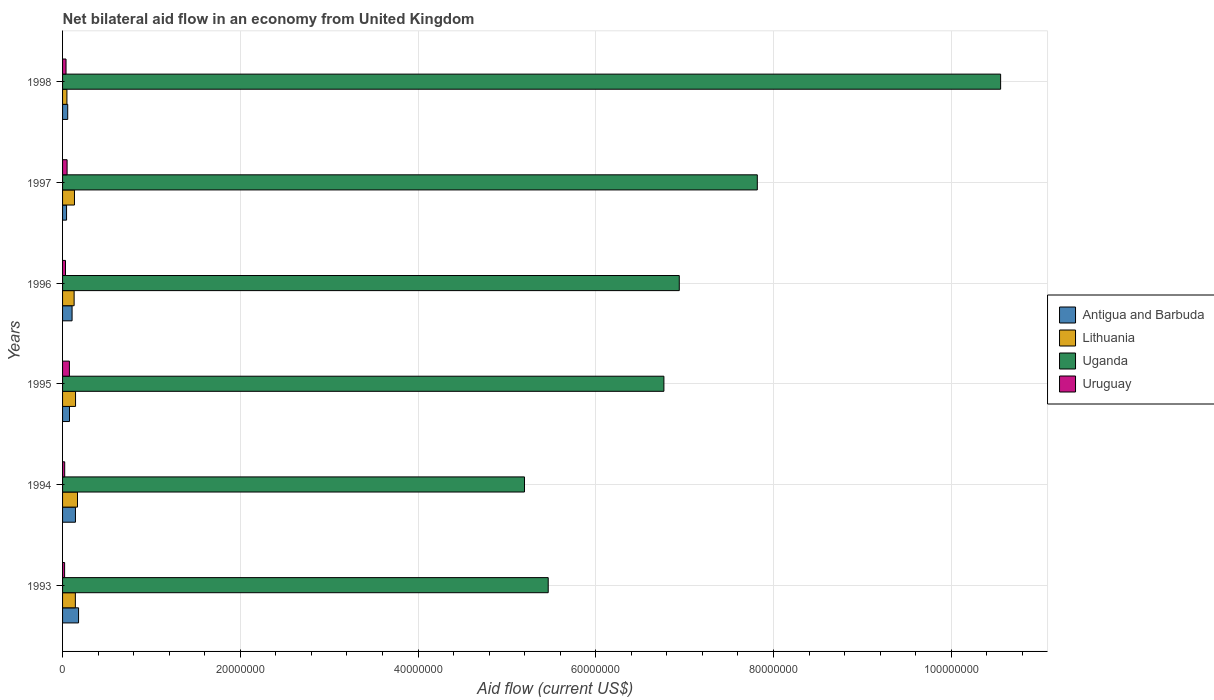How many different coloured bars are there?
Make the answer very short. 4. Are the number of bars per tick equal to the number of legend labels?
Your answer should be very brief. Yes. How many bars are there on the 4th tick from the top?
Keep it short and to the point. 4. What is the net bilateral aid flow in Lithuania in 1994?
Your response must be concise. 1.68e+06. Across all years, what is the maximum net bilateral aid flow in Uruguay?
Your answer should be very brief. 7.70e+05. What is the total net bilateral aid flow in Uruguay in the graph?
Make the answer very short. 2.47e+06. What is the difference between the net bilateral aid flow in Antigua and Barbuda in 1993 and that in 1994?
Offer a terse response. 3.50e+05. What is the difference between the net bilateral aid flow in Uganda in 1993 and the net bilateral aid flow in Uruguay in 1997?
Offer a very short reply. 5.41e+07. What is the average net bilateral aid flow in Lithuania per year?
Provide a succinct answer. 1.28e+06. In the year 1997, what is the difference between the net bilateral aid flow in Uruguay and net bilateral aid flow in Antigua and Barbuda?
Your answer should be very brief. 6.00e+04. What is the ratio of the net bilateral aid flow in Uruguay in 1995 to that in 1998?
Make the answer very short. 1.97. What is the difference between the highest and the lowest net bilateral aid flow in Uganda?
Your answer should be very brief. 5.36e+07. Is it the case that in every year, the sum of the net bilateral aid flow in Uruguay and net bilateral aid flow in Lithuania is greater than the sum of net bilateral aid flow in Uganda and net bilateral aid flow in Antigua and Barbuda?
Give a very brief answer. No. What does the 4th bar from the top in 1993 represents?
Your answer should be compact. Antigua and Barbuda. What does the 3rd bar from the bottom in 1994 represents?
Give a very brief answer. Uganda. Is it the case that in every year, the sum of the net bilateral aid flow in Uganda and net bilateral aid flow in Lithuania is greater than the net bilateral aid flow in Antigua and Barbuda?
Make the answer very short. Yes. How many bars are there?
Provide a short and direct response. 24. Are all the bars in the graph horizontal?
Your response must be concise. Yes. How many years are there in the graph?
Ensure brevity in your answer.  6. What is the difference between two consecutive major ticks on the X-axis?
Your response must be concise. 2.00e+07. Are the values on the major ticks of X-axis written in scientific E-notation?
Your answer should be compact. No. Where does the legend appear in the graph?
Your answer should be compact. Center right. How many legend labels are there?
Provide a succinct answer. 4. What is the title of the graph?
Provide a short and direct response. Net bilateral aid flow in an economy from United Kingdom. What is the label or title of the Y-axis?
Your answer should be compact. Years. What is the Aid flow (current US$) in Antigua and Barbuda in 1993?
Provide a succinct answer. 1.80e+06. What is the Aid flow (current US$) in Lithuania in 1993?
Your answer should be compact. 1.44e+06. What is the Aid flow (current US$) in Uganda in 1993?
Offer a very short reply. 5.46e+07. What is the Aid flow (current US$) in Uruguay in 1993?
Make the answer very short. 2.30e+05. What is the Aid flow (current US$) of Antigua and Barbuda in 1994?
Offer a terse response. 1.45e+06. What is the Aid flow (current US$) in Lithuania in 1994?
Ensure brevity in your answer.  1.68e+06. What is the Aid flow (current US$) in Uganda in 1994?
Keep it short and to the point. 5.20e+07. What is the Aid flow (current US$) in Antigua and Barbuda in 1995?
Your answer should be compact. 7.80e+05. What is the Aid flow (current US$) in Lithuania in 1995?
Your answer should be compact. 1.46e+06. What is the Aid flow (current US$) of Uganda in 1995?
Give a very brief answer. 6.77e+07. What is the Aid flow (current US$) in Uruguay in 1995?
Make the answer very short. 7.70e+05. What is the Aid flow (current US$) in Antigua and Barbuda in 1996?
Ensure brevity in your answer.  1.07e+06. What is the Aid flow (current US$) in Lithuania in 1996?
Your answer should be compact. 1.30e+06. What is the Aid flow (current US$) of Uganda in 1996?
Offer a very short reply. 6.94e+07. What is the Aid flow (current US$) in Uruguay in 1996?
Provide a succinct answer. 3.30e+05. What is the Aid flow (current US$) of Lithuania in 1997?
Make the answer very short. 1.34e+06. What is the Aid flow (current US$) in Uganda in 1997?
Provide a short and direct response. 7.82e+07. What is the Aid flow (current US$) in Uruguay in 1997?
Ensure brevity in your answer.  5.10e+05. What is the Aid flow (current US$) in Antigua and Barbuda in 1998?
Make the answer very short. 5.80e+05. What is the Aid flow (current US$) of Uganda in 1998?
Make the answer very short. 1.06e+08. What is the Aid flow (current US$) of Uruguay in 1998?
Your response must be concise. 3.90e+05. Across all years, what is the maximum Aid flow (current US$) in Antigua and Barbuda?
Offer a terse response. 1.80e+06. Across all years, what is the maximum Aid flow (current US$) of Lithuania?
Your response must be concise. 1.68e+06. Across all years, what is the maximum Aid flow (current US$) of Uganda?
Your response must be concise. 1.06e+08. Across all years, what is the maximum Aid flow (current US$) of Uruguay?
Provide a short and direct response. 7.70e+05. Across all years, what is the minimum Aid flow (current US$) in Lithuania?
Offer a very short reply. 4.90e+05. Across all years, what is the minimum Aid flow (current US$) in Uganda?
Your response must be concise. 5.20e+07. Across all years, what is the minimum Aid flow (current US$) in Uruguay?
Your answer should be very brief. 2.30e+05. What is the total Aid flow (current US$) of Antigua and Barbuda in the graph?
Offer a very short reply. 6.13e+06. What is the total Aid flow (current US$) in Lithuania in the graph?
Make the answer very short. 7.71e+06. What is the total Aid flow (current US$) of Uganda in the graph?
Provide a short and direct response. 4.27e+08. What is the total Aid flow (current US$) in Uruguay in the graph?
Ensure brevity in your answer.  2.47e+06. What is the difference between the Aid flow (current US$) of Antigua and Barbuda in 1993 and that in 1994?
Your answer should be very brief. 3.50e+05. What is the difference between the Aid flow (current US$) of Uganda in 1993 and that in 1994?
Ensure brevity in your answer.  2.67e+06. What is the difference between the Aid flow (current US$) of Antigua and Barbuda in 1993 and that in 1995?
Offer a terse response. 1.02e+06. What is the difference between the Aid flow (current US$) in Uganda in 1993 and that in 1995?
Make the answer very short. -1.30e+07. What is the difference between the Aid flow (current US$) in Uruguay in 1993 and that in 1995?
Your response must be concise. -5.40e+05. What is the difference between the Aid flow (current US$) in Antigua and Barbuda in 1993 and that in 1996?
Your answer should be compact. 7.30e+05. What is the difference between the Aid flow (current US$) of Uganda in 1993 and that in 1996?
Your response must be concise. -1.48e+07. What is the difference between the Aid flow (current US$) of Uruguay in 1993 and that in 1996?
Make the answer very short. -1.00e+05. What is the difference between the Aid flow (current US$) in Antigua and Barbuda in 1993 and that in 1997?
Offer a terse response. 1.35e+06. What is the difference between the Aid flow (current US$) of Uganda in 1993 and that in 1997?
Your answer should be compact. -2.35e+07. What is the difference between the Aid flow (current US$) in Uruguay in 1993 and that in 1997?
Give a very brief answer. -2.80e+05. What is the difference between the Aid flow (current US$) of Antigua and Barbuda in 1993 and that in 1998?
Provide a succinct answer. 1.22e+06. What is the difference between the Aid flow (current US$) of Lithuania in 1993 and that in 1998?
Offer a very short reply. 9.50e+05. What is the difference between the Aid flow (current US$) in Uganda in 1993 and that in 1998?
Provide a succinct answer. -5.09e+07. What is the difference between the Aid flow (current US$) of Antigua and Barbuda in 1994 and that in 1995?
Give a very brief answer. 6.70e+05. What is the difference between the Aid flow (current US$) of Uganda in 1994 and that in 1995?
Your answer should be compact. -1.57e+07. What is the difference between the Aid flow (current US$) of Uruguay in 1994 and that in 1995?
Make the answer very short. -5.30e+05. What is the difference between the Aid flow (current US$) in Antigua and Barbuda in 1994 and that in 1996?
Offer a very short reply. 3.80e+05. What is the difference between the Aid flow (current US$) of Uganda in 1994 and that in 1996?
Ensure brevity in your answer.  -1.74e+07. What is the difference between the Aid flow (current US$) of Antigua and Barbuda in 1994 and that in 1997?
Your answer should be compact. 1.00e+06. What is the difference between the Aid flow (current US$) of Uganda in 1994 and that in 1997?
Offer a very short reply. -2.62e+07. What is the difference between the Aid flow (current US$) in Uruguay in 1994 and that in 1997?
Offer a terse response. -2.70e+05. What is the difference between the Aid flow (current US$) in Antigua and Barbuda in 1994 and that in 1998?
Your answer should be very brief. 8.70e+05. What is the difference between the Aid flow (current US$) of Lithuania in 1994 and that in 1998?
Offer a terse response. 1.19e+06. What is the difference between the Aid flow (current US$) in Uganda in 1994 and that in 1998?
Give a very brief answer. -5.36e+07. What is the difference between the Aid flow (current US$) of Uruguay in 1994 and that in 1998?
Your answer should be compact. -1.50e+05. What is the difference between the Aid flow (current US$) of Antigua and Barbuda in 1995 and that in 1996?
Your response must be concise. -2.90e+05. What is the difference between the Aid flow (current US$) of Lithuania in 1995 and that in 1996?
Your answer should be very brief. 1.60e+05. What is the difference between the Aid flow (current US$) in Uganda in 1995 and that in 1996?
Ensure brevity in your answer.  -1.73e+06. What is the difference between the Aid flow (current US$) in Uruguay in 1995 and that in 1996?
Give a very brief answer. 4.40e+05. What is the difference between the Aid flow (current US$) of Uganda in 1995 and that in 1997?
Your answer should be very brief. -1.05e+07. What is the difference between the Aid flow (current US$) in Antigua and Barbuda in 1995 and that in 1998?
Keep it short and to the point. 2.00e+05. What is the difference between the Aid flow (current US$) in Lithuania in 1995 and that in 1998?
Your answer should be very brief. 9.70e+05. What is the difference between the Aid flow (current US$) in Uganda in 1995 and that in 1998?
Offer a very short reply. -3.79e+07. What is the difference between the Aid flow (current US$) in Antigua and Barbuda in 1996 and that in 1997?
Make the answer very short. 6.20e+05. What is the difference between the Aid flow (current US$) in Uganda in 1996 and that in 1997?
Make the answer very short. -8.78e+06. What is the difference between the Aid flow (current US$) of Uruguay in 1996 and that in 1997?
Your answer should be compact. -1.80e+05. What is the difference between the Aid flow (current US$) in Lithuania in 1996 and that in 1998?
Keep it short and to the point. 8.10e+05. What is the difference between the Aid flow (current US$) of Uganda in 1996 and that in 1998?
Ensure brevity in your answer.  -3.62e+07. What is the difference between the Aid flow (current US$) of Uruguay in 1996 and that in 1998?
Give a very brief answer. -6.00e+04. What is the difference between the Aid flow (current US$) of Lithuania in 1997 and that in 1998?
Your answer should be compact. 8.50e+05. What is the difference between the Aid flow (current US$) in Uganda in 1997 and that in 1998?
Give a very brief answer. -2.74e+07. What is the difference between the Aid flow (current US$) of Antigua and Barbuda in 1993 and the Aid flow (current US$) of Lithuania in 1994?
Offer a terse response. 1.20e+05. What is the difference between the Aid flow (current US$) in Antigua and Barbuda in 1993 and the Aid flow (current US$) in Uganda in 1994?
Your response must be concise. -5.02e+07. What is the difference between the Aid flow (current US$) of Antigua and Barbuda in 1993 and the Aid flow (current US$) of Uruguay in 1994?
Provide a succinct answer. 1.56e+06. What is the difference between the Aid flow (current US$) of Lithuania in 1993 and the Aid flow (current US$) of Uganda in 1994?
Your answer should be very brief. -5.05e+07. What is the difference between the Aid flow (current US$) of Lithuania in 1993 and the Aid flow (current US$) of Uruguay in 1994?
Offer a very short reply. 1.20e+06. What is the difference between the Aid flow (current US$) of Uganda in 1993 and the Aid flow (current US$) of Uruguay in 1994?
Keep it short and to the point. 5.44e+07. What is the difference between the Aid flow (current US$) of Antigua and Barbuda in 1993 and the Aid flow (current US$) of Lithuania in 1995?
Provide a short and direct response. 3.40e+05. What is the difference between the Aid flow (current US$) of Antigua and Barbuda in 1993 and the Aid flow (current US$) of Uganda in 1995?
Your answer should be very brief. -6.59e+07. What is the difference between the Aid flow (current US$) in Antigua and Barbuda in 1993 and the Aid flow (current US$) in Uruguay in 1995?
Offer a very short reply. 1.03e+06. What is the difference between the Aid flow (current US$) of Lithuania in 1993 and the Aid flow (current US$) of Uganda in 1995?
Provide a short and direct response. -6.62e+07. What is the difference between the Aid flow (current US$) in Lithuania in 1993 and the Aid flow (current US$) in Uruguay in 1995?
Make the answer very short. 6.70e+05. What is the difference between the Aid flow (current US$) of Uganda in 1993 and the Aid flow (current US$) of Uruguay in 1995?
Offer a terse response. 5.39e+07. What is the difference between the Aid flow (current US$) of Antigua and Barbuda in 1993 and the Aid flow (current US$) of Uganda in 1996?
Ensure brevity in your answer.  -6.76e+07. What is the difference between the Aid flow (current US$) in Antigua and Barbuda in 1993 and the Aid flow (current US$) in Uruguay in 1996?
Your response must be concise. 1.47e+06. What is the difference between the Aid flow (current US$) of Lithuania in 1993 and the Aid flow (current US$) of Uganda in 1996?
Keep it short and to the point. -6.80e+07. What is the difference between the Aid flow (current US$) in Lithuania in 1993 and the Aid flow (current US$) in Uruguay in 1996?
Your response must be concise. 1.11e+06. What is the difference between the Aid flow (current US$) of Uganda in 1993 and the Aid flow (current US$) of Uruguay in 1996?
Your answer should be compact. 5.43e+07. What is the difference between the Aid flow (current US$) in Antigua and Barbuda in 1993 and the Aid flow (current US$) in Uganda in 1997?
Provide a succinct answer. -7.64e+07. What is the difference between the Aid flow (current US$) in Antigua and Barbuda in 1993 and the Aid flow (current US$) in Uruguay in 1997?
Your response must be concise. 1.29e+06. What is the difference between the Aid flow (current US$) of Lithuania in 1993 and the Aid flow (current US$) of Uganda in 1997?
Keep it short and to the point. -7.67e+07. What is the difference between the Aid flow (current US$) in Lithuania in 1993 and the Aid flow (current US$) in Uruguay in 1997?
Offer a terse response. 9.30e+05. What is the difference between the Aid flow (current US$) in Uganda in 1993 and the Aid flow (current US$) in Uruguay in 1997?
Offer a terse response. 5.41e+07. What is the difference between the Aid flow (current US$) in Antigua and Barbuda in 1993 and the Aid flow (current US$) in Lithuania in 1998?
Provide a short and direct response. 1.31e+06. What is the difference between the Aid flow (current US$) in Antigua and Barbuda in 1993 and the Aid flow (current US$) in Uganda in 1998?
Give a very brief answer. -1.04e+08. What is the difference between the Aid flow (current US$) in Antigua and Barbuda in 1993 and the Aid flow (current US$) in Uruguay in 1998?
Give a very brief answer. 1.41e+06. What is the difference between the Aid flow (current US$) of Lithuania in 1993 and the Aid flow (current US$) of Uganda in 1998?
Your response must be concise. -1.04e+08. What is the difference between the Aid flow (current US$) of Lithuania in 1993 and the Aid flow (current US$) of Uruguay in 1998?
Your response must be concise. 1.05e+06. What is the difference between the Aid flow (current US$) in Uganda in 1993 and the Aid flow (current US$) in Uruguay in 1998?
Provide a succinct answer. 5.43e+07. What is the difference between the Aid flow (current US$) in Antigua and Barbuda in 1994 and the Aid flow (current US$) in Uganda in 1995?
Your answer should be compact. -6.62e+07. What is the difference between the Aid flow (current US$) of Antigua and Barbuda in 1994 and the Aid flow (current US$) of Uruguay in 1995?
Provide a succinct answer. 6.80e+05. What is the difference between the Aid flow (current US$) in Lithuania in 1994 and the Aid flow (current US$) in Uganda in 1995?
Your response must be concise. -6.60e+07. What is the difference between the Aid flow (current US$) in Lithuania in 1994 and the Aid flow (current US$) in Uruguay in 1995?
Offer a terse response. 9.10e+05. What is the difference between the Aid flow (current US$) of Uganda in 1994 and the Aid flow (current US$) of Uruguay in 1995?
Offer a very short reply. 5.12e+07. What is the difference between the Aid flow (current US$) in Antigua and Barbuda in 1994 and the Aid flow (current US$) in Lithuania in 1996?
Your response must be concise. 1.50e+05. What is the difference between the Aid flow (current US$) of Antigua and Barbuda in 1994 and the Aid flow (current US$) of Uganda in 1996?
Give a very brief answer. -6.80e+07. What is the difference between the Aid flow (current US$) in Antigua and Barbuda in 1994 and the Aid flow (current US$) in Uruguay in 1996?
Give a very brief answer. 1.12e+06. What is the difference between the Aid flow (current US$) in Lithuania in 1994 and the Aid flow (current US$) in Uganda in 1996?
Give a very brief answer. -6.77e+07. What is the difference between the Aid flow (current US$) of Lithuania in 1994 and the Aid flow (current US$) of Uruguay in 1996?
Your answer should be very brief. 1.35e+06. What is the difference between the Aid flow (current US$) of Uganda in 1994 and the Aid flow (current US$) of Uruguay in 1996?
Make the answer very short. 5.16e+07. What is the difference between the Aid flow (current US$) in Antigua and Barbuda in 1994 and the Aid flow (current US$) in Uganda in 1997?
Ensure brevity in your answer.  -7.67e+07. What is the difference between the Aid flow (current US$) in Antigua and Barbuda in 1994 and the Aid flow (current US$) in Uruguay in 1997?
Offer a very short reply. 9.40e+05. What is the difference between the Aid flow (current US$) in Lithuania in 1994 and the Aid flow (current US$) in Uganda in 1997?
Keep it short and to the point. -7.65e+07. What is the difference between the Aid flow (current US$) of Lithuania in 1994 and the Aid flow (current US$) of Uruguay in 1997?
Make the answer very short. 1.17e+06. What is the difference between the Aid flow (current US$) in Uganda in 1994 and the Aid flow (current US$) in Uruguay in 1997?
Keep it short and to the point. 5.15e+07. What is the difference between the Aid flow (current US$) of Antigua and Barbuda in 1994 and the Aid flow (current US$) of Lithuania in 1998?
Provide a short and direct response. 9.60e+05. What is the difference between the Aid flow (current US$) in Antigua and Barbuda in 1994 and the Aid flow (current US$) in Uganda in 1998?
Your answer should be very brief. -1.04e+08. What is the difference between the Aid flow (current US$) of Antigua and Barbuda in 1994 and the Aid flow (current US$) of Uruguay in 1998?
Your answer should be compact. 1.06e+06. What is the difference between the Aid flow (current US$) in Lithuania in 1994 and the Aid flow (current US$) in Uganda in 1998?
Your response must be concise. -1.04e+08. What is the difference between the Aid flow (current US$) of Lithuania in 1994 and the Aid flow (current US$) of Uruguay in 1998?
Ensure brevity in your answer.  1.29e+06. What is the difference between the Aid flow (current US$) of Uganda in 1994 and the Aid flow (current US$) of Uruguay in 1998?
Your answer should be very brief. 5.16e+07. What is the difference between the Aid flow (current US$) in Antigua and Barbuda in 1995 and the Aid flow (current US$) in Lithuania in 1996?
Ensure brevity in your answer.  -5.20e+05. What is the difference between the Aid flow (current US$) of Antigua and Barbuda in 1995 and the Aid flow (current US$) of Uganda in 1996?
Provide a short and direct response. -6.86e+07. What is the difference between the Aid flow (current US$) of Lithuania in 1995 and the Aid flow (current US$) of Uganda in 1996?
Offer a very short reply. -6.79e+07. What is the difference between the Aid flow (current US$) in Lithuania in 1995 and the Aid flow (current US$) in Uruguay in 1996?
Your answer should be compact. 1.13e+06. What is the difference between the Aid flow (current US$) of Uganda in 1995 and the Aid flow (current US$) of Uruguay in 1996?
Keep it short and to the point. 6.73e+07. What is the difference between the Aid flow (current US$) in Antigua and Barbuda in 1995 and the Aid flow (current US$) in Lithuania in 1997?
Offer a terse response. -5.60e+05. What is the difference between the Aid flow (current US$) of Antigua and Barbuda in 1995 and the Aid flow (current US$) of Uganda in 1997?
Give a very brief answer. -7.74e+07. What is the difference between the Aid flow (current US$) in Lithuania in 1995 and the Aid flow (current US$) in Uganda in 1997?
Your answer should be very brief. -7.67e+07. What is the difference between the Aid flow (current US$) of Lithuania in 1995 and the Aid flow (current US$) of Uruguay in 1997?
Offer a very short reply. 9.50e+05. What is the difference between the Aid flow (current US$) in Uganda in 1995 and the Aid flow (current US$) in Uruguay in 1997?
Make the answer very short. 6.72e+07. What is the difference between the Aid flow (current US$) of Antigua and Barbuda in 1995 and the Aid flow (current US$) of Uganda in 1998?
Your response must be concise. -1.05e+08. What is the difference between the Aid flow (current US$) of Antigua and Barbuda in 1995 and the Aid flow (current US$) of Uruguay in 1998?
Make the answer very short. 3.90e+05. What is the difference between the Aid flow (current US$) of Lithuania in 1995 and the Aid flow (current US$) of Uganda in 1998?
Provide a succinct answer. -1.04e+08. What is the difference between the Aid flow (current US$) of Lithuania in 1995 and the Aid flow (current US$) of Uruguay in 1998?
Provide a short and direct response. 1.07e+06. What is the difference between the Aid flow (current US$) of Uganda in 1995 and the Aid flow (current US$) of Uruguay in 1998?
Keep it short and to the point. 6.73e+07. What is the difference between the Aid flow (current US$) of Antigua and Barbuda in 1996 and the Aid flow (current US$) of Uganda in 1997?
Your answer should be very brief. -7.71e+07. What is the difference between the Aid flow (current US$) in Antigua and Barbuda in 1996 and the Aid flow (current US$) in Uruguay in 1997?
Your answer should be very brief. 5.60e+05. What is the difference between the Aid flow (current US$) of Lithuania in 1996 and the Aid flow (current US$) of Uganda in 1997?
Offer a terse response. -7.69e+07. What is the difference between the Aid flow (current US$) of Lithuania in 1996 and the Aid flow (current US$) of Uruguay in 1997?
Make the answer very short. 7.90e+05. What is the difference between the Aid flow (current US$) of Uganda in 1996 and the Aid flow (current US$) of Uruguay in 1997?
Your answer should be very brief. 6.89e+07. What is the difference between the Aid flow (current US$) in Antigua and Barbuda in 1996 and the Aid flow (current US$) in Lithuania in 1998?
Your answer should be compact. 5.80e+05. What is the difference between the Aid flow (current US$) in Antigua and Barbuda in 1996 and the Aid flow (current US$) in Uganda in 1998?
Keep it short and to the point. -1.04e+08. What is the difference between the Aid flow (current US$) in Antigua and Barbuda in 1996 and the Aid flow (current US$) in Uruguay in 1998?
Provide a short and direct response. 6.80e+05. What is the difference between the Aid flow (current US$) of Lithuania in 1996 and the Aid flow (current US$) of Uganda in 1998?
Provide a short and direct response. -1.04e+08. What is the difference between the Aid flow (current US$) of Lithuania in 1996 and the Aid flow (current US$) of Uruguay in 1998?
Provide a succinct answer. 9.10e+05. What is the difference between the Aid flow (current US$) in Uganda in 1996 and the Aid flow (current US$) in Uruguay in 1998?
Make the answer very short. 6.90e+07. What is the difference between the Aid flow (current US$) in Antigua and Barbuda in 1997 and the Aid flow (current US$) in Lithuania in 1998?
Give a very brief answer. -4.00e+04. What is the difference between the Aid flow (current US$) of Antigua and Barbuda in 1997 and the Aid flow (current US$) of Uganda in 1998?
Offer a terse response. -1.05e+08. What is the difference between the Aid flow (current US$) in Lithuania in 1997 and the Aid flow (current US$) in Uganda in 1998?
Provide a succinct answer. -1.04e+08. What is the difference between the Aid flow (current US$) of Lithuania in 1997 and the Aid flow (current US$) of Uruguay in 1998?
Provide a succinct answer. 9.50e+05. What is the difference between the Aid flow (current US$) in Uganda in 1997 and the Aid flow (current US$) in Uruguay in 1998?
Keep it short and to the point. 7.78e+07. What is the average Aid flow (current US$) in Antigua and Barbuda per year?
Give a very brief answer. 1.02e+06. What is the average Aid flow (current US$) of Lithuania per year?
Provide a short and direct response. 1.28e+06. What is the average Aid flow (current US$) of Uganda per year?
Offer a very short reply. 7.12e+07. What is the average Aid flow (current US$) of Uruguay per year?
Make the answer very short. 4.12e+05. In the year 1993, what is the difference between the Aid flow (current US$) of Antigua and Barbuda and Aid flow (current US$) of Uganda?
Your response must be concise. -5.28e+07. In the year 1993, what is the difference between the Aid flow (current US$) in Antigua and Barbuda and Aid flow (current US$) in Uruguay?
Your answer should be very brief. 1.57e+06. In the year 1993, what is the difference between the Aid flow (current US$) of Lithuania and Aid flow (current US$) of Uganda?
Make the answer very short. -5.32e+07. In the year 1993, what is the difference between the Aid flow (current US$) of Lithuania and Aid flow (current US$) of Uruguay?
Make the answer very short. 1.21e+06. In the year 1993, what is the difference between the Aid flow (current US$) in Uganda and Aid flow (current US$) in Uruguay?
Your answer should be very brief. 5.44e+07. In the year 1994, what is the difference between the Aid flow (current US$) of Antigua and Barbuda and Aid flow (current US$) of Uganda?
Give a very brief answer. -5.05e+07. In the year 1994, what is the difference between the Aid flow (current US$) of Antigua and Barbuda and Aid flow (current US$) of Uruguay?
Make the answer very short. 1.21e+06. In the year 1994, what is the difference between the Aid flow (current US$) of Lithuania and Aid flow (current US$) of Uganda?
Provide a succinct answer. -5.03e+07. In the year 1994, what is the difference between the Aid flow (current US$) in Lithuania and Aid flow (current US$) in Uruguay?
Provide a short and direct response. 1.44e+06. In the year 1994, what is the difference between the Aid flow (current US$) in Uganda and Aid flow (current US$) in Uruguay?
Make the answer very short. 5.17e+07. In the year 1995, what is the difference between the Aid flow (current US$) of Antigua and Barbuda and Aid flow (current US$) of Lithuania?
Provide a short and direct response. -6.80e+05. In the year 1995, what is the difference between the Aid flow (current US$) of Antigua and Barbuda and Aid flow (current US$) of Uganda?
Keep it short and to the point. -6.69e+07. In the year 1995, what is the difference between the Aid flow (current US$) of Antigua and Barbuda and Aid flow (current US$) of Uruguay?
Your response must be concise. 10000. In the year 1995, what is the difference between the Aid flow (current US$) in Lithuania and Aid flow (current US$) in Uganda?
Give a very brief answer. -6.62e+07. In the year 1995, what is the difference between the Aid flow (current US$) in Lithuania and Aid flow (current US$) in Uruguay?
Provide a short and direct response. 6.90e+05. In the year 1995, what is the difference between the Aid flow (current US$) of Uganda and Aid flow (current US$) of Uruguay?
Keep it short and to the point. 6.69e+07. In the year 1996, what is the difference between the Aid flow (current US$) in Antigua and Barbuda and Aid flow (current US$) in Uganda?
Your answer should be compact. -6.83e+07. In the year 1996, what is the difference between the Aid flow (current US$) in Antigua and Barbuda and Aid flow (current US$) in Uruguay?
Give a very brief answer. 7.40e+05. In the year 1996, what is the difference between the Aid flow (current US$) in Lithuania and Aid flow (current US$) in Uganda?
Ensure brevity in your answer.  -6.81e+07. In the year 1996, what is the difference between the Aid flow (current US$) in Lithuania and Aid flow (current US$) in Uruguay?
Make the answer very short. 9.70e+05. In the year 1996, what is the difference between the Aid flow (current US$) of Uganda and Aid flow (current US$) of Uruguay?
Keep it short and to the point. 6.91e+07. In the year 1997, what is the difference between the Aid flow (current US$) of Antigua and Barbuda and Aid flow (current US$) of Lithuania?
Keep it short and to the point. -8.90e+05. In the year 1997, what is the difference between the Aid flow (current US$) in Antigua and Barbuda and Aid flow (current US$) in Uganda?
Provide a succinct answer. -7.77e+07. In the year 1997, what is the difference between the Aid flow (current US$) of Lithuania and Aid flow (current US$) of Uganda?
Give a very brief answer. -7.68e+07. In the year 1997, what is the difference between the Aid flow (current US$) in Lithuania and Aid flow (current US$) in Uruguay?
Ensure brevity in your answer.  8.30e+05. In the year 1997, what is the difference between the Aid flow (current US$) of Uganda and Aid flow (current US$) of Uruguay?
Provide a succinct answer. 7.77e+07. In the year 1998, what is the difference between the Aid flow (current US$) in Antigua and Barbuda and Aid flow (current US$) in Lithuania?
Keep it short and to the point. 9.00e+04. In the year 1998, what is the difference between the Aid flow (current US$) of Antigua and Barbuda and Aid flow (current US$) of Uganda?
Offer a terse response. -1.05e+08. In the year 1998, what is the difference between the Aid flow (current US$) in Antigua and Barbuda and Aid flow (current US$) in Uruguay?
Your answer should be very brief. 1.90e+05. In the year 1998, what is the difference between the Aid flow (current US$) of Lithuania and Aid flow (current US$) of Uganda?
Provide a succinct answer. -1.05e+08. In the year 1998, what is the difference between the Aid flow (current US$) of Uganda and Aid flow (current US$) of Uruguay?
Your response must be concise. 1.05e+08. What is the ratio of the Aid flow (current US$) in Antigua and Barbuda in 1993 to that in 1994?
Offer a terse response. 1.24. What is the ratio of the Aid flow (current US$) in Uganda in 1993 to that in 1994?
Your answer should be compact. 1.05. What is the ratio of the Aid flow (current US$) in Uruguay in 1993 to that in 1994?
Make the answer very short. 0.96. What is the ratio of the Aid flow (current US$) in Antigua and Barbuda in 1993 to that in 1995?
Your response must be concise. 2.31. What is the ratio of the Aid flow (current US$) in Lithuania in 1993 to that in 1995?
Your answer should be very brief. 0.99. What is the ratio of the Aid flow (current US$) in Uganda in 1993 to that in 1995?
Make the answer very short. 0.81. What is the ratio of the Aid flow (current US$) of Uruguay in 1993 to that in 1995?
Your response must be concise. 0.3. What is the ratio of the Aid flow (current US$) of Antigua and Barbuda in 1993 to that in 1996?
Your response must be concise. 1.68. What is the ratio of the Aid flow (current US$) of Lithuania in 1993 to that in 1996?
Your answer should be compact. 1.11. What is the ratio of the Aid flow (current US$) in Uganda in 1993 to that in 1996?
Give a very brief answer. 0.79. What is the ratio of the Aid flow (current US$) of Uruguay in 1993 to that in 1996?
Give a very brief answer. 0.7. What is the ratio of the Aid flow (current US$) of Antigua and Barbuda in 1993 to that in 1997?
Provide a succinct answer. 4. What is the ratio of the Aid flow (current US$) of Lithuania in 1993 to that in 1997?
Your response must be concise. 1.07. What is the ratio of the Aid flow (current US$) in Uganda in 1993 to that in 1997?
Your answer should be compact. 0.7. What is the ratio of the Aid flow (current US$) in Uruguay in 1993 to that in 1997?
Provide a short and direct response. 0.45. What is the ratio of the Aid flow (current US$) in Antigua and Barbuda in 1993 to that in 1998?
Your answer should be compact. 3.1. What is the ratio of the Aid flow (current US$) in Lithuania in 1993 to that in 1998?
Make the answer very short. 2.94. What is the ratio of the Aid flow (current US$) of Uganda in 1993 to that in 1998?
Ensure brevity in your answer.  0.52. What is the ratio of the Aid flow (current US$) in Uruguay in 1993 to that in 1998?
Your response must be concise. 0.59. What is the ratio of the Aid flow (current US$) in Antigua and Barbuda in 1994 to that in 1995?
Your response must be concise. 1.86. What is the ratio of the Aid flow (current US$) of Lithuania in 1994 to that in 1995?
Give a very brief answer. 1.15. What is the ratio of the Aid flow (current US$) in Uganda in 1994 to that in 1995?
Make the answer very short. 0.77. What is the ratio of the Aid flow (current US$) of Uruguay in 1994 to that in 1995?
Keep it short and to the point. 0.31. What is the ratio of the Aid flow (current US$) in Antigua and Barbuda in 1994 to that in 1996?
Provide a succinct answer. 1.36. What is the ratio of the Aid flow (current US$) in Lithuania in 1994 to that in 1996?
Provide a succinct answer. 1.29. What is the ratio of the Aid flow (current US$) of Uganda in 1994 to that in 1996?
Provide a succinct answer. 0.75. What is the ratio of the Aid flow (current US$) of Uruguay in 1994 to that in 1996?
Keep it short and to the point. 0.73. What is the ratio of the Aid flow (current US$) of Antigua and Barbuda in 1994 to that in 1997?
Ensure brevity in your answer.  3.22. What is the ratio of the Aid flow (current US$) in Lithuania in 1994 to that in 1997?
Offer a very short reply. 1.25. What is the ratio of the Aid flow (current US$) in Uganda in 1994 to that in 1997?
Ensure brevity in your answer.  0.66. What is the ratio of the Aid flow (current US$) of Uruguay in 1994 to that in 1997?
Offer a very short reply. 0.47. What is the ratio of the Aid flow (current US$) in Lithuania in 1994 to that in 1998?
Offer a very short reply. 3.43. What is the ratio of the Aid flow (current US$) of Uganda in 1994 to that in 1998?
Offer a terse response. 0.49. What is the ratio of the Aid flow (current US$) of Uruguay in 1994 to that in 1998?
Offer a very short reply. 0.62. What is the ratio of the Aid flow (current US$) in Antigua and Barbuda in 1995 to that in 1996?
Offer a very short reply. 0.73. What is the ratio of the Aid flow (current US$) of Lithuania in 1995 to that in 1996?
Keep it short and to the point. 1.12. What is the ratio of the Aid flow (current US$) in Uganda in 1995 to that in 1996?
Your answer should be very brief. 0.98. What is the ratio of the Aid flow (current US$) of Uruguay in 1995 to that in 1996?
Provide a succinct answer. 2.33. What is the ratio of the Aid flow (current US$) in Antigua and Barbuda in 1995 to that in 1997?
Provide a short and direct response. 1.73. What is the ratio of the Aid flow (current US$) in Lithuania in 1995 to that in 1997?
Provide a succinct answer. 1.09. What is the ratio of the Aid flow (current US$) of Uganda in 1995 to that in 1997?
Your response must be concise. 0.87. What is the ratio of the Aid flow (current US$) of Uruguay in 1995 to that in 1997?
Offer a terse response. 1.51. What is the ratio of the Aid flow (current US$) in Antigua and Barbuda in 1995 to that in 1998?
Offer a very short reply. 1.34. What is the ratio of the Aid flow (current US$) in Lithuania in 1995 to that in 1998?
Keep it short and to the point. 2.98. What is the ratio of the Aid flow (current US$) in Uganda in 1995 to that in 1998?
Ensure brevity in your answer.  0.64. What is the ratio of the Aid flow (current US$) of Uruguay in 1995 to that in 1998?
Provide a succinct answer. 1.97. What is the ratio of the Aid flow (current US$) in Antigua and Barbuda in 1996 to that in 1997?
Give a very brief answer. 2.38. What is the ratio of the Aid flow (current US$) in Lithuania in 1996 to that in 1997?
Keep it short and to the point. 0.97. What is the ratio of the Aid flow (current US$) of Uganda in 1996 to that in 1997?
Make the answer very short. 0.89. What is the ratio of the Aid flow (current US$) in Uruguay in 1996 to that in 1997?
Keep it short and to the point. 0.65. What is the ratio of the Aid flow (current US$) in Antigua and Barbuda in 1996 to that in 1998?
Make the answer very short. 1.84. What is the ratio of the Aid flow (current US$) of Lithuania in 1996 to that in 1998?
Provide a succinct answer. 2.65. What is the ratio of the Aid flow (current US$) in Uganda in 1996 to that in 1998?
Ensure brevity in your answer.  0.66. What is the ratio of the Aid flow (current US$) of Uruguay in 1996 to that in 1998?
Offer a very short reply. 0.85. What is the ratio of the Aid flow (current US$) of Antigua and Barbuda in 1997 to that in 1998?
Ensure brevity in your answer.  0.78. What is the ratio of the Aid flow (current US$) in Lithuania in 1997 to that in 1998?
Offer a terse response. 2.73. What is the ratio of the Aid flow (current US$) in Uganda in 1997 to that in 1998?
Offer a very short reply. 0.74. What is the ratio of the Aid flow (current US$) of Uruguay in 1997 to that in 1998?
Offer a very short reply. 1.31. What is the difference between the highest and the second highest Aid flow (current US$) in Antigua and Barbuda?
Your answer should be very brief. 3.50e+05. What is the difference between the highest and the second highest Aid flow (current US$) of Lithuania?
Offer a very short reply. 2.20e+05. What is the difference between the highest and the second highest Aid flow (current US$) in Uganda?
Your answer should be very brief. 2.74e+07. What is the difference between the highest and the second highest Aid flow (current US$) in Uruguay?
Make the answer very short. 2.60e+05. What is the difference between the highest and the lowest Aid flow (current US$) of Antigua and Barbuda?
Make the answer very short. 1.35e+06. What is the difference between the highest and the lowest Aid flow (current US$) of Lithuania?
Provide a short and direct response. 1.19e+06. What is the difference between the highest and the lowest Aid flow (current US$) of Uganda?
Keep it short and to the point. 5.36e+07. What is the difference between the highest and the lowest Aid flow (current US$) in Uruguay?
Your response must be concise. 5.40e+05. 